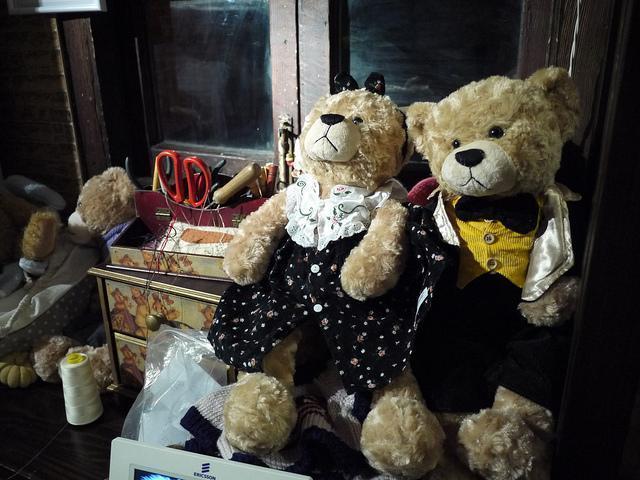How many bears are there in the picture?
Give a very brief answer. 3. How many teddy bears are in the picture?
Give a very brief answer. 3. 